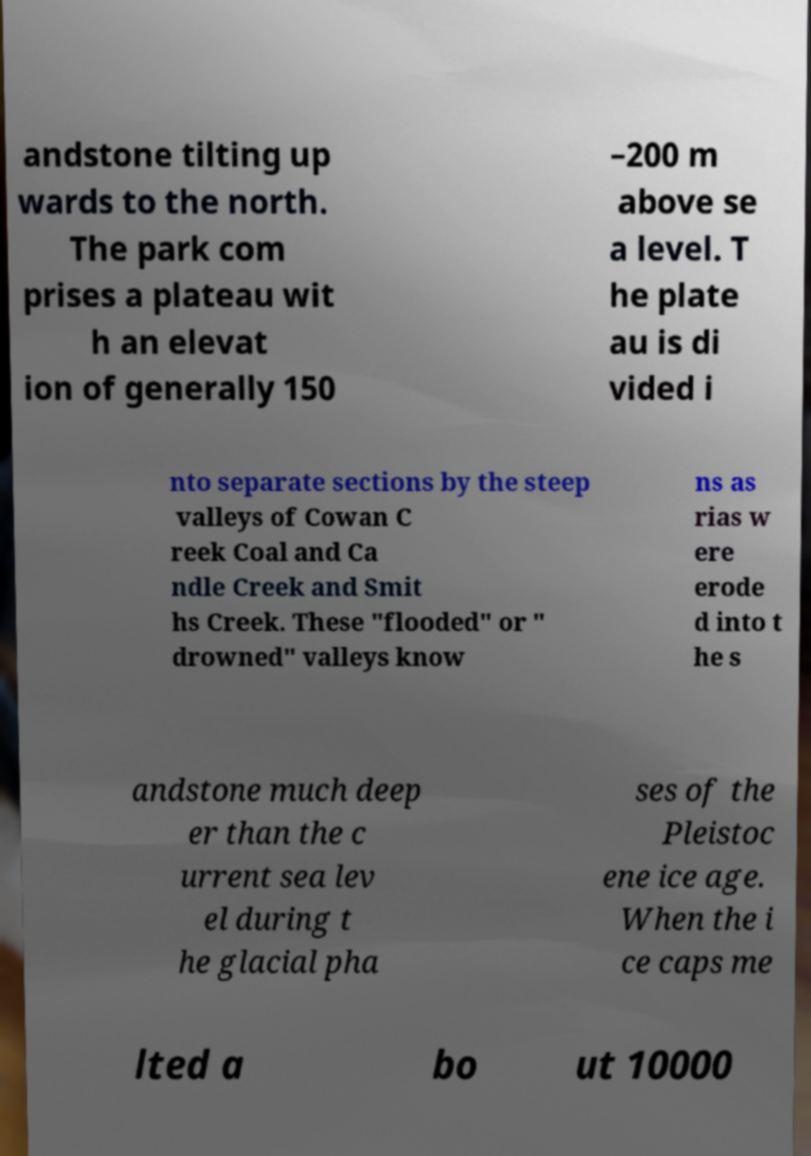What messages or text are displayed in this image? I need them in a readable, typed format. andstone tilting up wards to the north. The park com prises a plateau wit h an elevat ion of generally 150 –200 m above se a level. T he plate au is di vided i nto separate sections by the steep valleys of Cowan C reek Coal and Ca ndle Creek and Smit hs Creek. These "flooded" or " drowned" valleys know ns as rias w ere erode d into t he s andstone much deep er than the c urrent sea lev el during t he glacial pha ses of the Pleistoc ene ice age. When the i ce caps me lted a bo ut 10000 